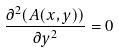<formula> <loc_0><loc_0><loc_500><loc_500>\frac { \partial ^ { 2 } ( A ( x , y ) ) } { \partial y ^ { 2 } } = 0</formula> 